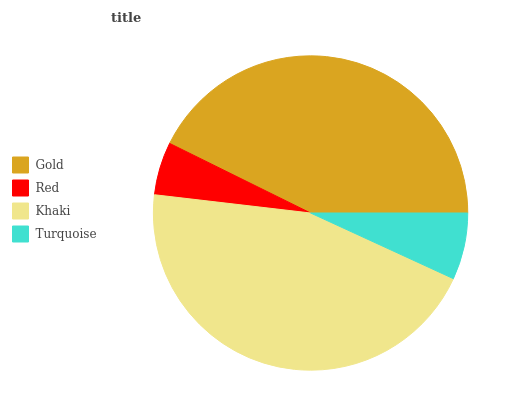Is Red the minimum?
Answer yes or no. Yes. Is Khaki the maximum?
Answer yes or no. Yes. Is Khaki the minimum?
Answer yes or no. No. Is Red the maximum?
Answer yes or no. No. Is Khaki greater than Red?
Answer yes or no. Yes. Is Red less than Khaki?
Answer yes or no. Yes. Is Red greater than Khaki?
Answer yes or no. No. Is Khaki less than Red?
Answer yes or no. No. Is Gold the high median?
Answer yes or no. Yes. Is Turquoise the low median?
Answer yes or no. Yes. Is Red the high median?
Answer yes or no. No. Is Khaki the low median?
Answer yes or no. No. 